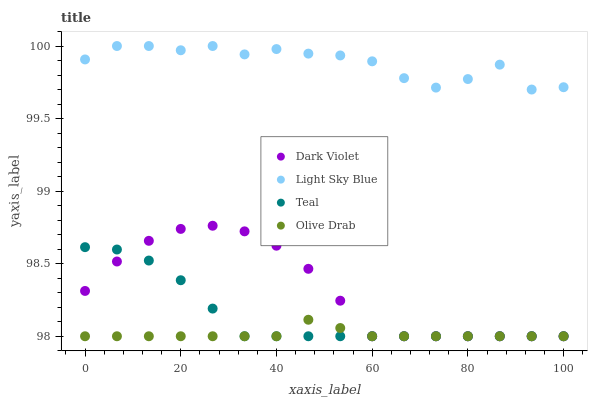Does Olive Drab have the minimum area under the curve?
Answer yes or no. Yes. Does Light Sky Blue have the maximum area under the curve?
Answer yes or no. Yes. Does Teal have the minimum area under the curve?
Answer yes or no. No. Does Teal have the maximum area under the curve?
Answer yes or no. No. Is Olive Drab the smoothest?
Answer yes or no. Yes. Is Light Sky Blue the roughest?
Answer yes or no. Yes. Is Teal the smoothest?
Answer yes or no. No. Is Teal the roughest?
Answer yes or no. No. Does Olive Drab have the lowest value?
Answer yes or no. Yes. Does Light Sky Blue have the lowest value?
Answer yes or no. No. Does Light Sky Blue have the highest value?
Answer yes or no. Yes. Does Teal have the highest value?
Answer yes or no. No. Is Teal less than Light Sky Blue?
Answer yes or no. Yes. Is Light Sky Blue greater than Olive Drab?
Answer yes or no. Yes. Does Teal intersect Dark Violet?
Answer yes or no. Yes. Is Teal less than Dark Violet?
Answer yes or no. No. Is Teal greater than Dark Violet?
Answer yes or no. No. Does Teal intersect Light Sky Blue?
Answer yes or no. No. 